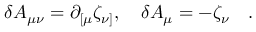<formula> <loc_0><loc_0><loc_500><loc_500>\delta A _ { \mu \nu } = \partial _ { [ \mu } \zeta _ { \nu ] } , \quad \delta A _ { \mu } = - \zeta _ { \nu } \quad .</formula> 